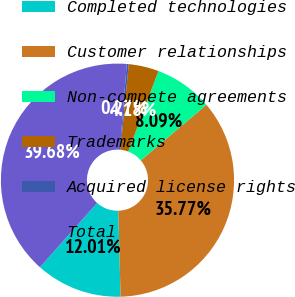<chart> <loc_0><loc_0><loc_500><loc_500><pie_chart><fcel>Completed technologies<fcel>Customer relationships<fcel>Non-compete agreements<fcel>Trademarks<fcel>Acquired license rights<fcel>Total<nl><fcel>12.01%<fcel>35.77%<fcel>8.09%<fcel>4.18%<fcel>0.27%<fcel>39.68%<nl></chart> 